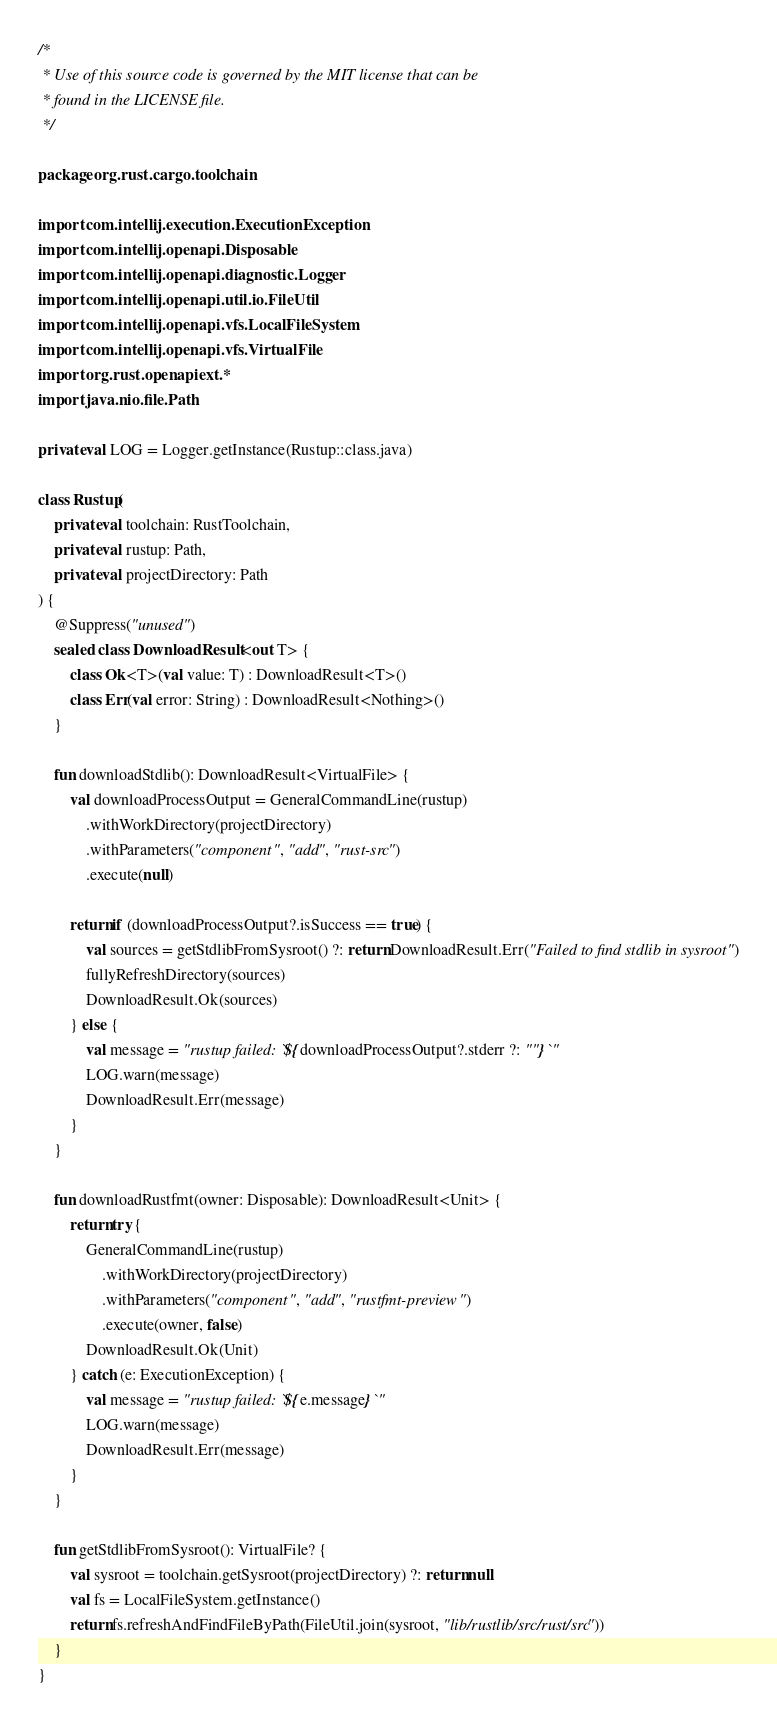Convert code to text. <code><loc_0><loc_0><loc_500><loc_500><_Kotlin_>/*
 * Use of this source code is governed by the MIT license that can be
 * found in the LICENSE file.
 */

package org.rust.cargo.toolchain

import com.intellij.execution.ExecutionException
import com.intellij.openapi.Disposable
import com.intellij.openapi.diagnostic.Logger
import com.intellij.openapi.util.io.FileUtil
import com.intellij.openapi.vfs.LocalFileSystem
import com.intellij.openapi.vfs.VirtualFile
import org.rust.openapiext.*
import java.nio.file.Path

private val LOG = Logger.getInstance(Rustup::class.java)

class Rustup(
    private val toolchain: RustToolchain,
    private val rustup: Path,
    private val projectDirectory: Path
) {
    @Suppress("unused")
    sealed class DownloadResult<out T> {
        class Ok<T>(val value: T) : DownloadResult<T>()
        class Err(val error: String) : DownloadResult<Nothing>()
    }

    fun downloadStdlib(): DownloadResult<VirtualFile> {
        val downloadProcessOutput = GeneralCommandLine(rustup)
            .withWorkDirectory(projectDirectory)
            .withParameters("component", "add", "rust-src")
            .execute(null)

        return if (downloadProcessOutput?.isSuccess == true) {
            val sources = getStdlibFromSysroot() ?: return DownloadResult.Err("Failed to find stdlib in sysroot")
            fullyRefreshDirectory(sources)
            DownloadResult.Ok(sources)
        } else {
            val message = "rustup failed: `${downloadProcessOutput?.stderr ?: ""}`"
            LOG.warn(message)
            DownloadResult.Err(message)
        }
    }

    fun downloadRustfmt(owner: Disposable): DownloadResult<Unit> {
        return try {
            GeneralCommandLine(rustup)
                .withWorkDirectory(projectDirectory)
                .withParameters("component", "add", "rustfmt-preview")
                .execute(owner, false)
            DownloadResult.Ok(Unit)
        } catch (e: ExecutionException) {
            val message = "rustup failed: `${e.message}`"
            LOG.warn(message)
            DownloadResult.Err(message)
        }
    }

    fun getStdlibFromSysroot(): VirtualFile? {
        val sysroot = toolchain.getSysroot(projectDirectory) ?: return null
        val fs = LocalFileSystem.getInstance()
        return fs.refreshAndFindFileByPath(FileUtil.join(sysroot, "lib/rustlib/src/rust/src"))
    }
}
</code> 